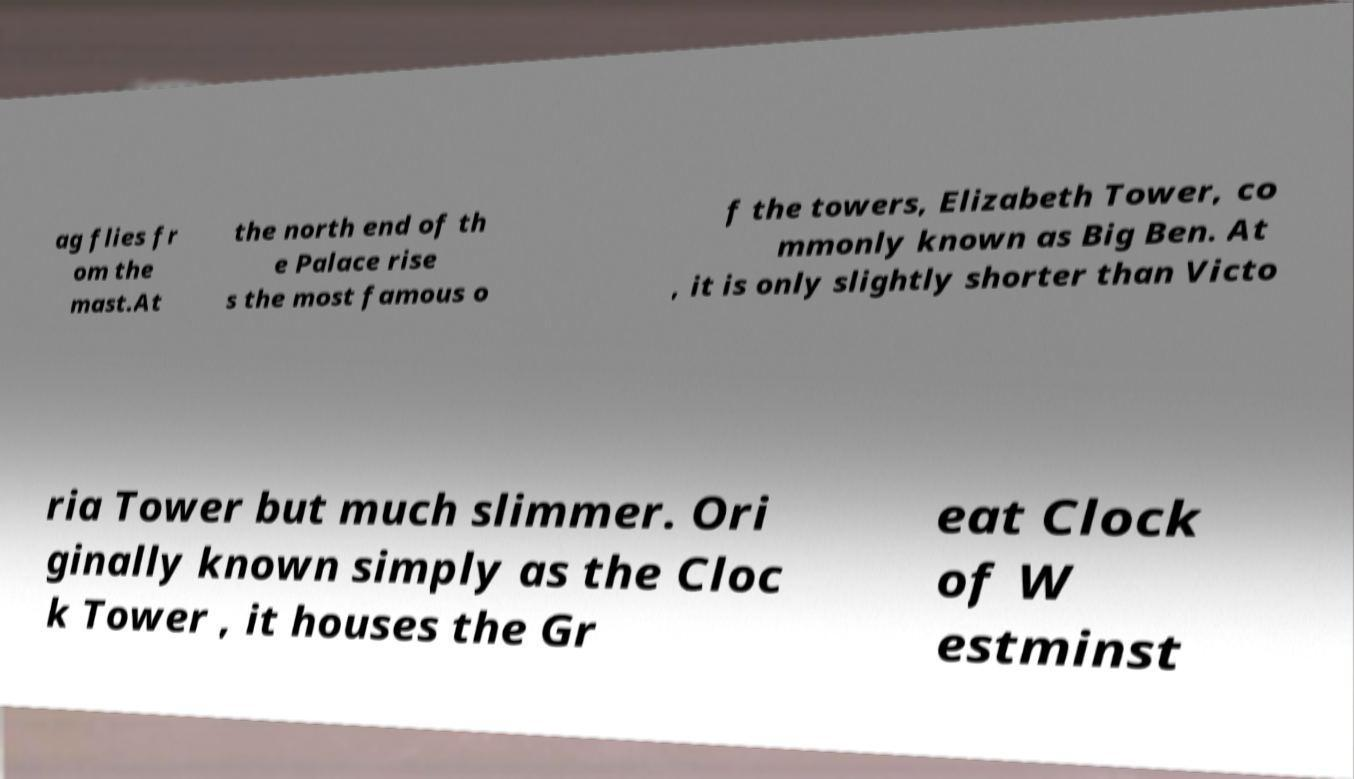There's text embedded in this image that I need extracted. Can you transcribe it verbatim? ag flies fr om the mast.At the north end of th e Palace rise s the most famous o f the towers, Elizabeth Tower, co mmonly known as Big Ben. At , it is only slightly shorter than Victo ria Tower but much slimmer. Ori ginally known simply as the Cloc k Tower , it houses the Gr eat Clock of W estminst 